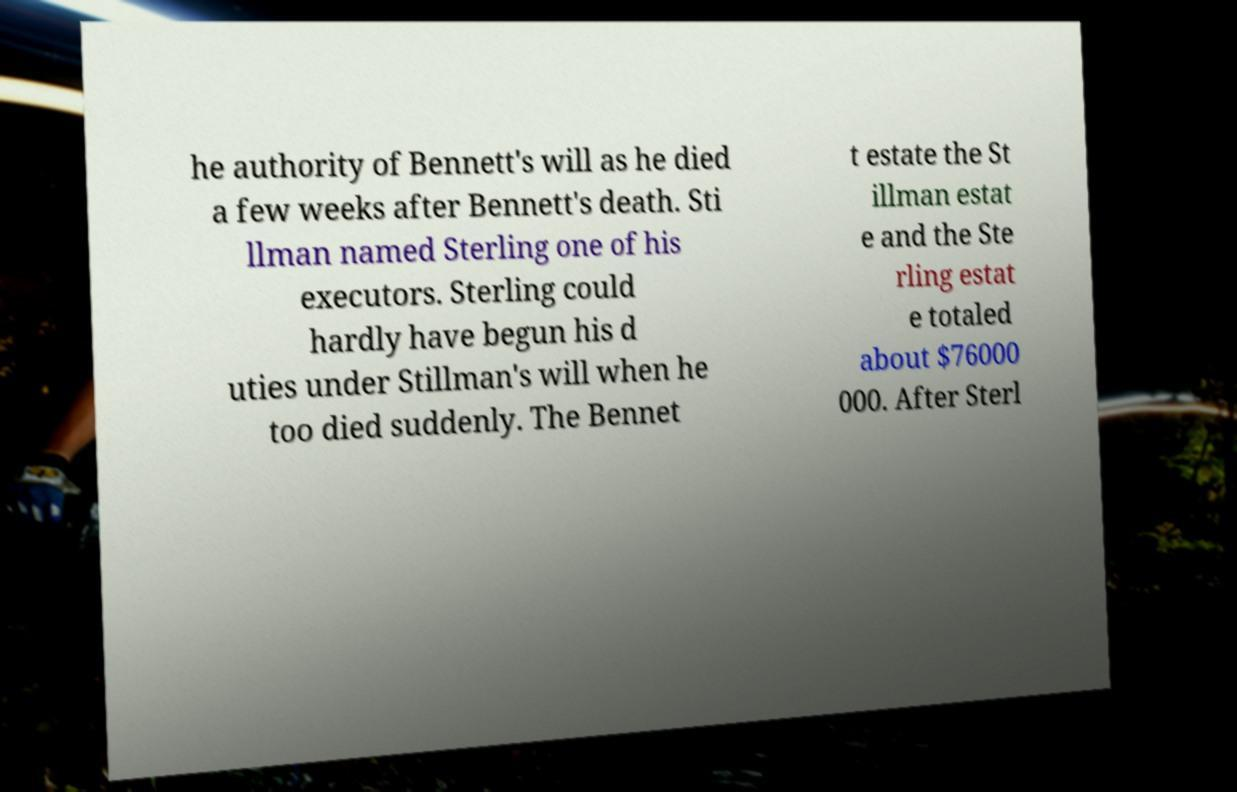Please identify and transcribe the text found in this image. he authority of Bennett's will as he died a few weeks after Bennett's death. Sti llman named Sterling one of his executors. Sterling could hardly have begun his d uties under Stillman's will when he too died suddenly. The Bennet t estate the St illman estat e and the Ste rling estat e totaled about $76000 000. After Sterl 